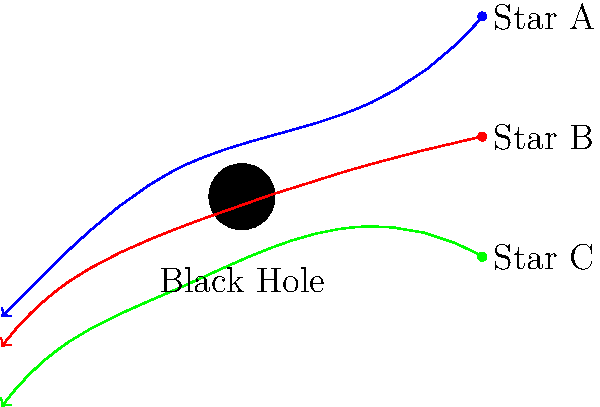In a sci-fi film scene, you're tasked with creating a visual effect of gravitational lensing around a black hole. The image shows light paths from three stars (A, B, and C) bending around the black hole. If the mass of the black hole were to double, how would this affect the curvature of the light paths? To answer this question, we need to understand the relationship between a black hole's mass and its gravitational lensing effect:

1. Gravitational lensing is caused by the curvature of spacetime around massive objects, as described by Einstein's theory of general relativity.

2. The strength of the gravitational field is directly proportional to the mass of the object. In this case, the object is the black hole.

3. The deflection angle of light passing near a massive object is given by the equation:

   $$\theta = \frac{4GM}{c^2b}$$

   Where:
   $\theta$ is the deflection angle
   $G$ is the gravitational constant
   $M$ is the mass of the object (black hole)
   $c$ is the speed of light
   $b$ is the impact parameter (closest approach of the light to the black hole)

4. From this equation, we can see that the deflection angle $\theta$ is directly proportional to the mass $M$ of the black hole.

5. If the mass of the black hole doubles, the deflection angle will also double for any given impact parameter.

6. In the context of the visual effect, this means that the curvature of the light paths would become more pronounced. The light paths would bend more sharply around the black hole.

7. Visually, this would result in the curved light paths appearing closer to the black hole and having a tighter curve.
Answer: The light paths would curve more sharply, bending closer to the black hole. 